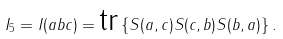<formula> <loc_0><loc_0><loc_500><loc_500>I _ { 5 } = I ( a b c ) = \text {tr} \left \{ S ( a , c ) S ( c , b ) S ( b , a ) \right \} .</formula> 